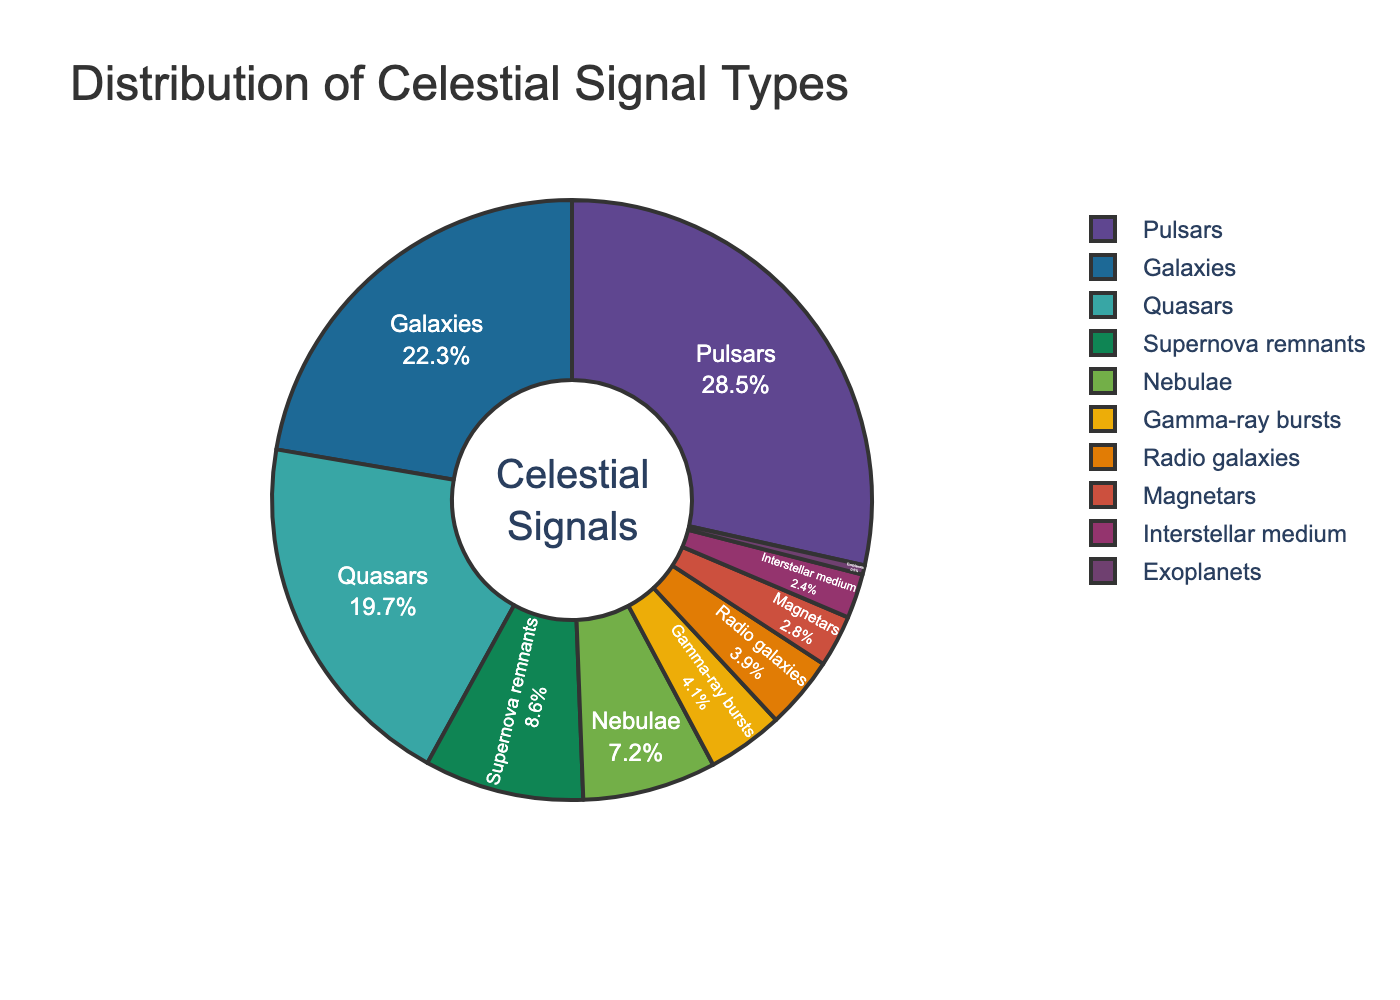which celestial signal type has the largest percentage? To answer this, identify the section of the pie chart with the largest size. The label on this section will indicate the celestial signal type with the highest percentage.
Answer: Pulsars compare the percentages of quasars and gamma-ray bursts. Which is larger and by how much? From the pie chart, locate the sections labeled "Quasars" and "Gamma-ray bursts". Note their percentages: 19.7% for Quasars and 4.1% for Gamma-ray bursts. Calculate the difference: 19.7 - 4.1 = 15.6%. Thus, Quasars have a 15.6% larger share.
Answer: Quasars by 15.6% what is the combined percentage of supernova remnants, nebulae, and radio galaxies? Identify the sections labeled "Supernova remnants" (8.6%), "Nebulae" (7.2%), and "Radio galaxies" (3.9%). Sum these percentages: 8.6 + 7.2 + 3.9 = 19.7%.
Answer: 19.7% is the percentage of exoplanets greater than or less than the interstellar medium? From the pie chart, identify the percentages for "Exoplanets" (0.5%) and "Interstellar medium" (2.4%). Exoplanets have a smaller percentage than the Interstellar medium.
Answer: Less how much more percentage do galaxies have compared to magnetars? Locate the sections labeled "Galaxies" and "Magnetars" on the pie chart. The percentages are 22.3% for Galaxies and 2.8% for Magnetars. Calculate the difference: 22.3 - 2.8 = 19.5%. Galaxies have 19.5% more.
Answer: 19.5% what is the visual attribute that makes the legend more readable? The legend's readability is enhanced by using a combination of clear labels, distinct colors, and a large font size. These visual attributes help in distinguishing different sections easily.
Answer: clear labels, distinct colors, large font size are there more signals from galaxies or from all types combined except pulsars? Calculate the total percentage of all types except Pulsars: 100 - 28.5 = 71.5%. Compare this to the 22.3% from Galaxies. It is evident that the total of all other types is higher.
Answer: All types combined except pulsars what is the percentage difference between the smallest segment and gamma-ray bursts? Identify the smallest segment (Exoplanets at 0.5%) and compare it with the "Gamma-ray bursts" section (4.1%). Calculate the difference: 4.1 - 0.5 = 3.6%.
Answer: 3.6% if you sum up the percentages of pulsars and quasars, does their combined percentage exceed 40%? Locate the sections for "Pulsars" (28.5%) and "Quasars" (19.7%). Sum these percentages: 28.5 + 19.7 = 48.2%. Since 48.2% exceeds 40%, their combined percentage is greater than 40%.
Answer: Yes 